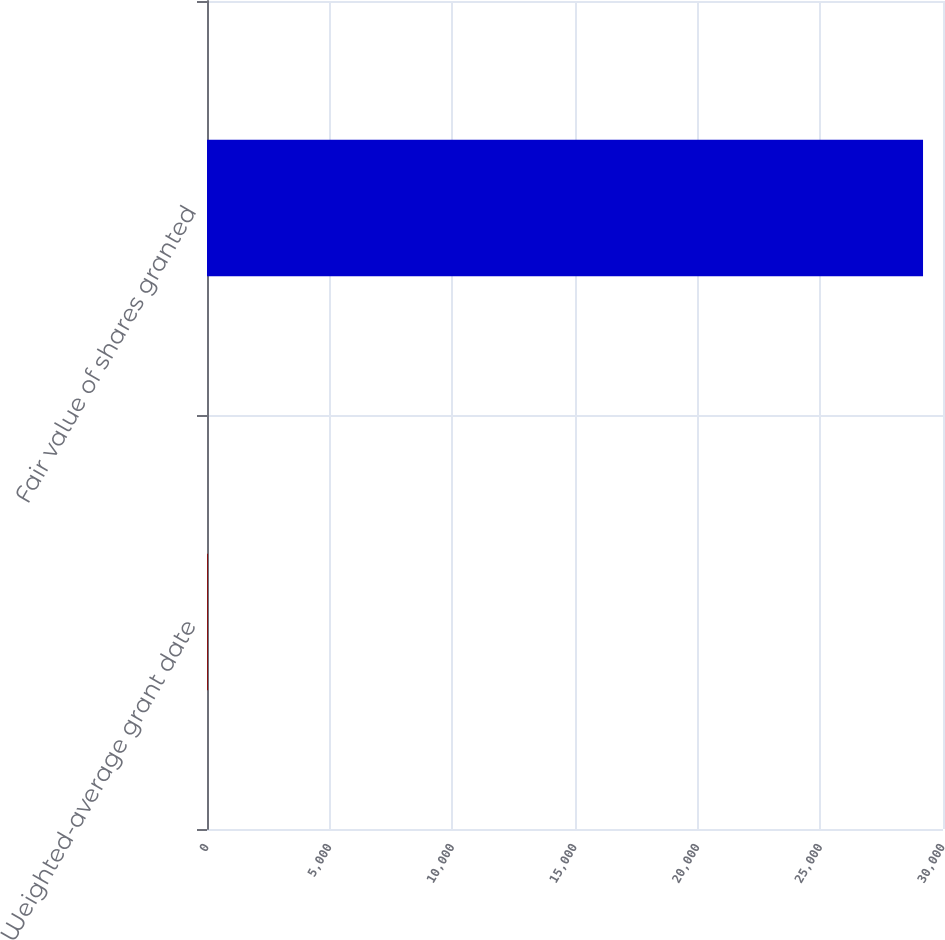<chart> <loc_0><loc_0><loc_500><loc_500><bar_chart><fcel>Weighted-average grant date<fcel>Fair value of shares granted<nl><fcel>34.68<fcel>29186<nl></chart> 